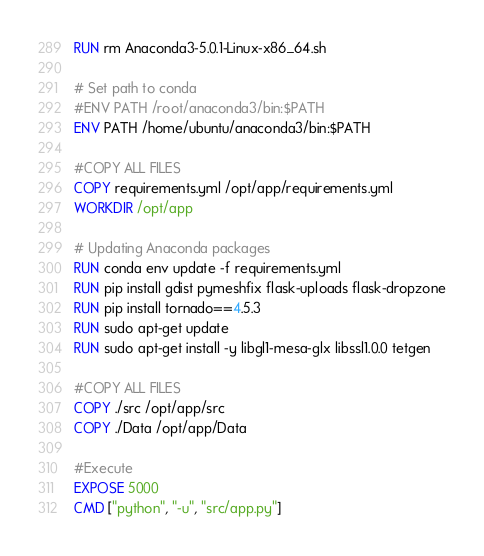<code> <loc_0><loc_0><loc_500><loc_500><_Dockerfile_>RUN rm Anaconda3-5.0.1-Linux-x86_64.sh

# Set path to conda 
#ENV PATH /root/anaconda3/bin:$PATH
ENV PATH /home/ubuntu/anaconda3/bin:$PATH

#COPY ALL FILES
COPY requirements.yml /opt/app/requirements.yml
WORKDIR /opt/app

# Updating Anaconda packages
RUN conda env update -f requirements.yml
RUN pip install gdist pymeshfix flask-uploads flask-dropzone
RUN pip install tornado==4.5.3
RUN sudo apt-get update
RUN sudo apt-get install -y libgl1-mesa-glx libssl1.0.0 tetgen

#COPY ALL FILES
COPY ./src /opt/app/src
COPY ./Data /opt/app/Data

#Execute 
EXPOSE 5000
CMD ["python", "-u", "src/app.py"]
</code> 